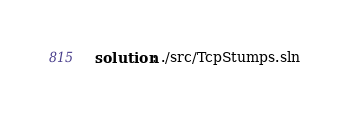Convert code to text. <code><loc_0><loc_0><loc_500><loc_500><_YAML_>solution: ./src/TcpStumps.sln</code> 